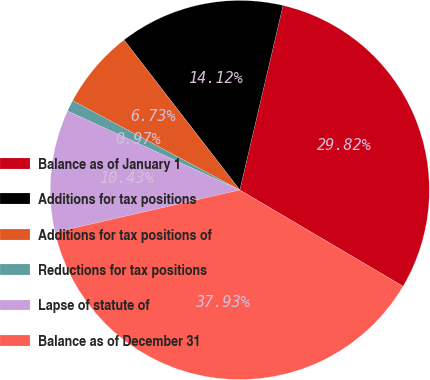Convert chart. <chart><loc_0><loc_0><loc_500><loc_500><pie_chart><fcel>Balance as of January 1<fcel>Additions for tax positions<fcel>Additions for tax positions of<fcel>Reductions for tax positions<fcel>Lapse of statute of<fcel>Balance as of December 31<nl><fcel>29.82%<fcel>14.12%<fcel>6.73%<fcel>0.97%<fcel>10.43%<fcel>37.93%<nl></chart> 